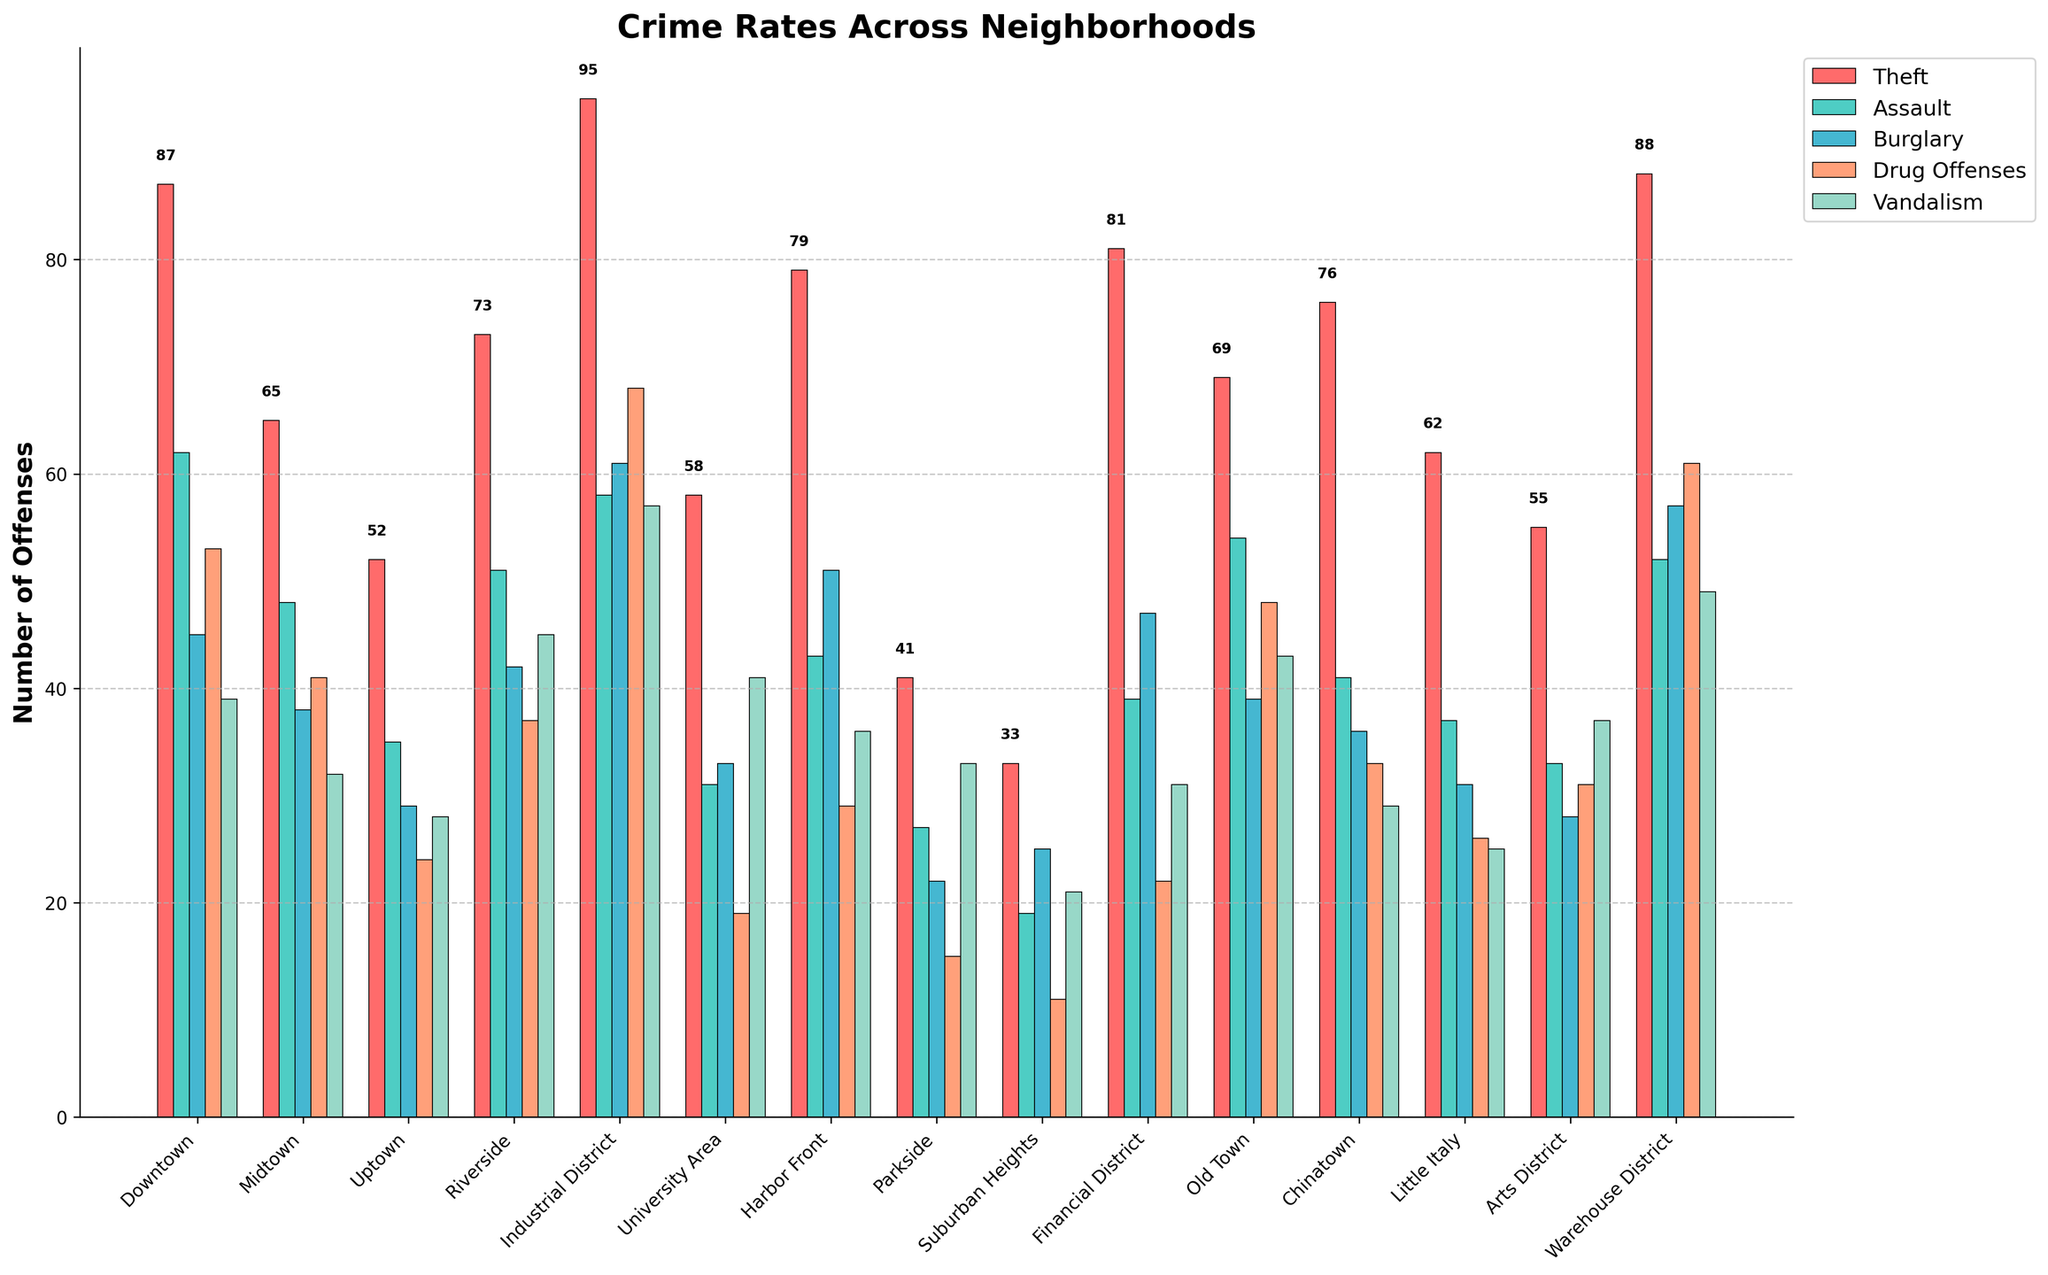Which neighborhood has the highest number of theft offenses? By looking at the bar with the highest height for theft offenses (red color), we see it is in the Industrial District.
Answer: Industrial District Which neighborhood reports the lowest number of vandalism incidents? Identify the shortest bar for vandalism offenses (light green color) across all neighborhoods. The shortest bar is in Suburban Heights.
Answer: Suburban Heights How many more assault incidents were reported in Downtown compared to Midtown? Find the height of the bars for assault offenses (turquoise color) in Downtown (62) and Midtown (48), then calculate the difference: 62 - 48 = 14.
Answer: 14 What is the total number of burglary offenses in Uptown and Riverside combined? Add the values of burglary offenses (middle blue bar) in Uptown (29) and Riverside (42): 29 + 42 = 71.
Answer: 71 Which type of crime is most prevalent in the University Area? Identify the tallest bar for University Area, which corresponds to theft offenses.
Answer: Theft Comparing drug offenses, which neighborhood has fewer incidents, Parkside or Little Italy? Compare the height of the bars for drug offenses (orange color) in Parkside (15) and Little Italy (26). Parkside has fewer incidents.
Answer: Parkside What is the average number of theft offenses across all neighborhoods? Sum the number of theft offenses in all neighborhoods and divide by the number of neighborhoods: (87+65+52+73+95+58+79+41+33+81+69+76+62+55+88) / 15 = 67.27 (rounded to two decimal places).
Answer: 67.27 Which neighborhood has the closest number of burglary offenses to the Financial District? Identify the number of burglary offenses in Financial District (47) and find the neighborhood with a value closest to this. Old Town with 39 is closest.
Answer: Old Town What is the difference between the total number of theft offenses and drug offenses in the Industrial District? Subtract the number of drug offenses (68) from the number of theft offenses (95) in the Industrial District: 95 - 68 = 27.
Answer: 27 What's the most common type of crime across all neighborhoods combined? Sum the number of each type of crime for all neighborhoods and determine the highest sum: Theft (1053), Assault (531), Burglary (524), Drug Offenses (488), Vandalism (511). Theft has the highest sum.
Answer: Theft 